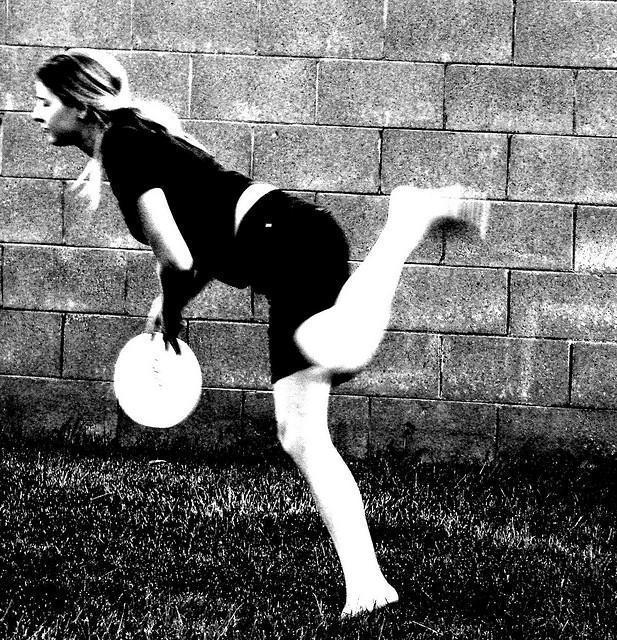How many dogs are to the right of the person?
Give a very brief answer. 0. 